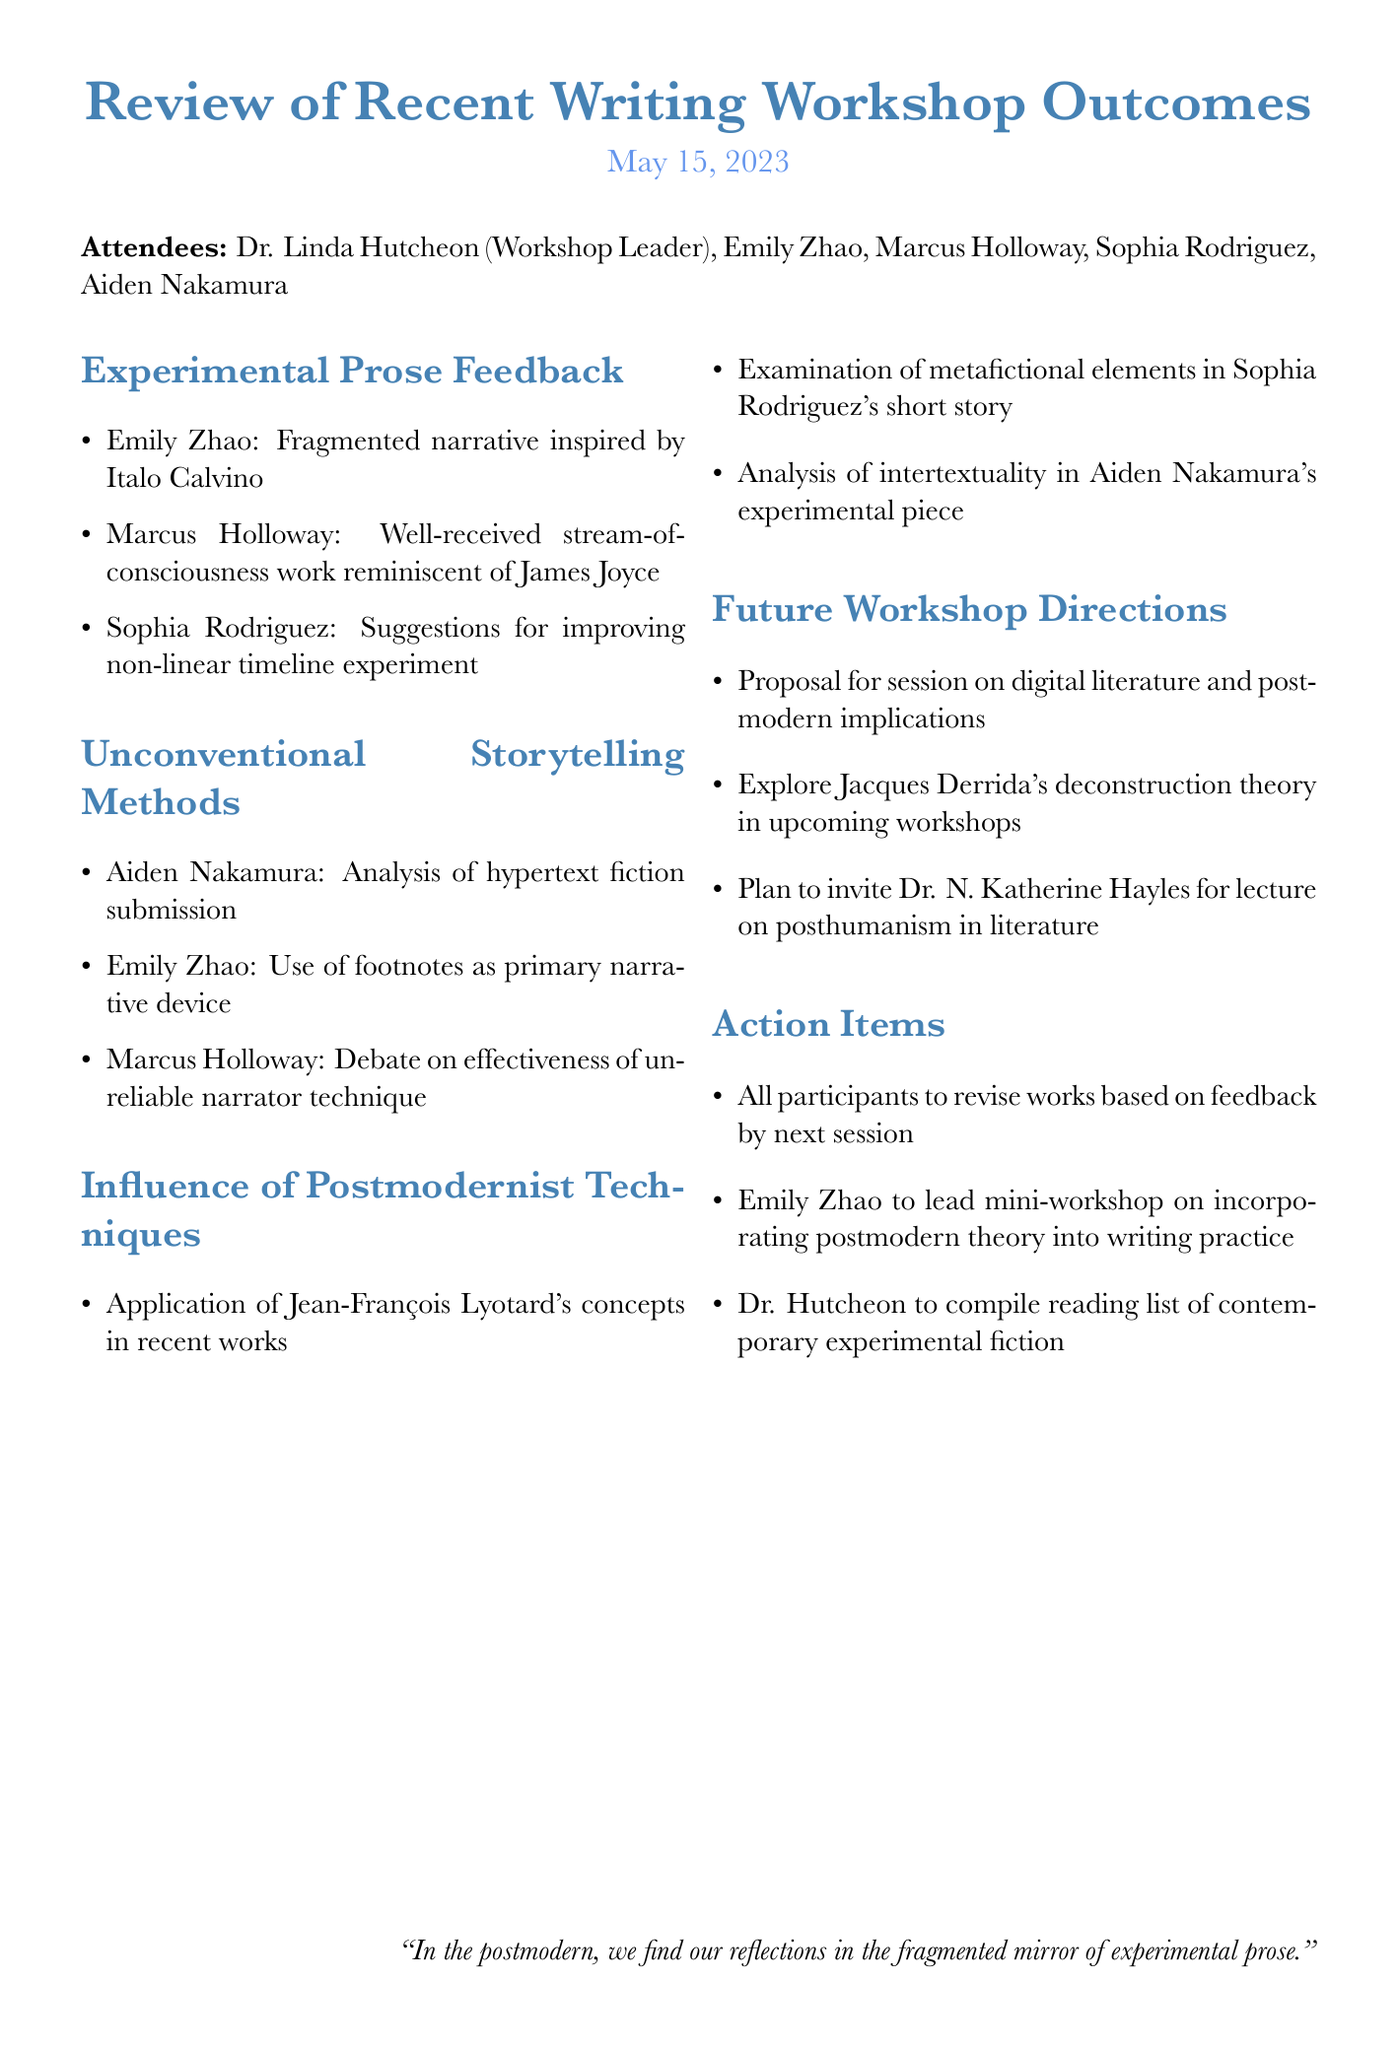What is the title of the meeting? The title is specified at the beginning of the document.
Answer: Review of Recent Writing Workshop Outcomes Who led the workshop? The workshop leader is mentioned in the attendees section.
Answer: Dr. Linda Hutcheon What date did the meeting take place? The date is listed right below the title of the document.
Answer: May 15, 2023 Which writer had a piece inspired by Italo Calvino? The feedback section for experimental prose identifies the writer and their inspiration.
Answer: Emily Zhao What upcoming topic is suggested for future workshops? The future workshop directions mention various proposals.
Answer: Digital literature and its postmodern implications Who is leading a mini-workshop on postmodern theory? The action items specify who will lead the mini-workshop.
Answer: Emily Zhao Which writer's work involves an unreliable narrator technique? The unconventional storytelling methods discuss this writer's technique.
Answer: Marcus Holloway What is one action item for all participants? The action items provide specific tasks for the attendees.
Answer: Revise their works based on feedback by next session What concept by Jean-François Lyotard was discussed in the meeting? The influence of postmodernist techniques includes a mention of specific concepts.
Answer: Application of Jean-François Lyotard's concepts 